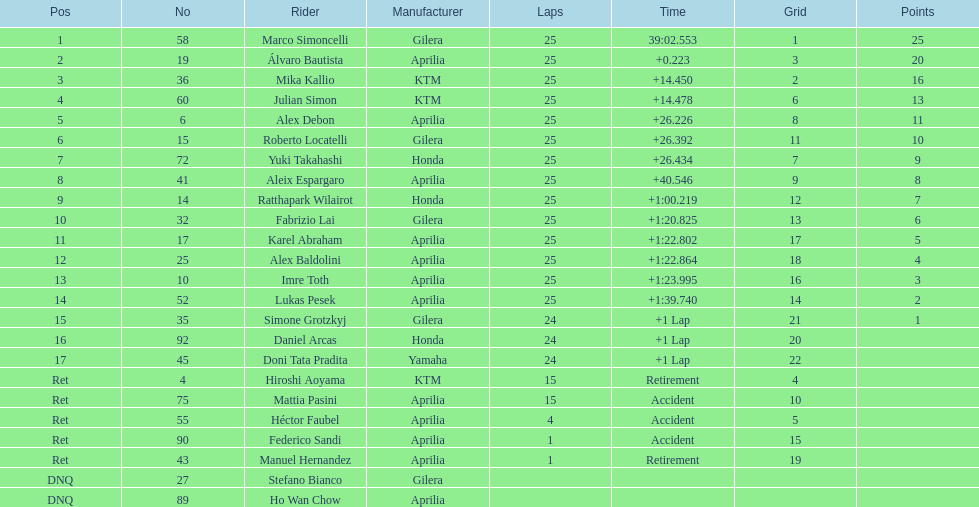Who is marco simoncelli's manufacturer Gilera. 